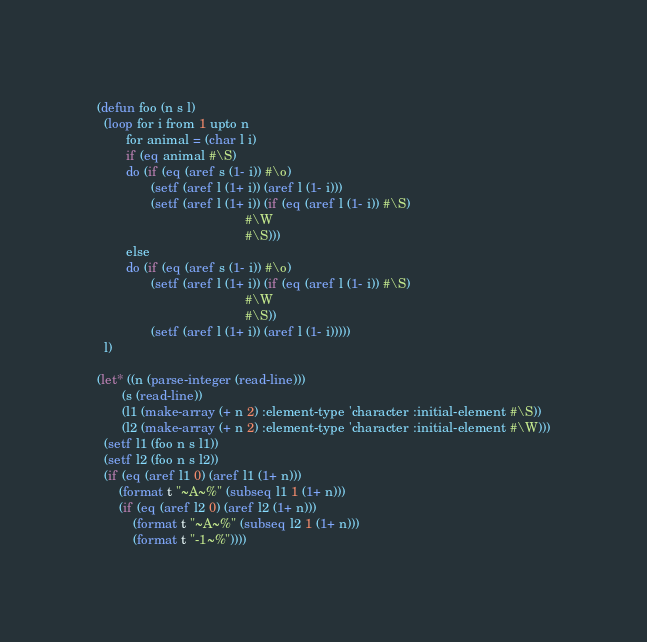Convert code to text. <code><loc_0><loc_0><loc_500><loc_500><_Lisp_>(defun foo (n s l)
  (loop for i from 1 upto n
        for animal = (char l i)
        if (eq animal #\S)
        do (if (eq (aref s (1- i)) #\o)
               (setf (aref l (1+ i)) (aref l (1- i)))
               (setf (aref l (1+ i)) (if (eq (aref l (1- i)) #\S)
                                         #\W
                                         #\S)))
        else
        do (if (eq (aref s (1- i)) #\o)
               (setf (aref l (1+ i)) (if (eq (aref l (1- i)) #\S)
                                         #\W
                                         #\S))
               (setf (aref l (1+ i)) (aref l (1- i)))))
  l)

(let* ((n (parse-integer (read-line)))
       (s (read-line))
       (l1 (make-array (+ n 2) :element-type 'character :initial-element #\S))
       (l2 (make-array (+ n 2) :element-type 'character :initial-element #\W)))
  (setf l1 (foo n s l1))
  (setf l2 (foo n s l2))
  (if (eq (aref l1 0) (aref l1 (1+ n)))
      (format t "~A~%" (subseq l1 1 (1+ n)))
      (if (eq (aref l2 0) (aref l2 (1+ n)))
          (format t "~A~%" (subseq l2 1 (1+ n)))
          (format t "-1~%"))))</code> 